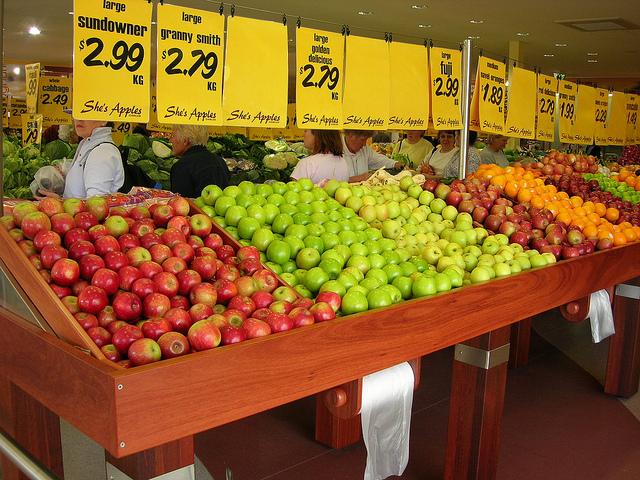How many different fruits are visible?
Answer briefly. 8. How much are large granny Smith apples?
Short answer required. 2.79. How many different grapes are there?
Concise answer only. 0. What type of fruit is displayed at the front of the picture?
Give a very brief answer. Apples. How many red signs can be seen?
Be succinct. 0. What kinds of fruits and vegetables are here?
Give a very brief answer. Apples and oranges. What color is the fruit on the left?
Be succinct. Red. What is being sold here?
Answer briefly. Apples. What color are the apples in the first bin?
Keep it brief. Red. Where are the rolls of plastic bags?
Concise answer only. Below shelf. 